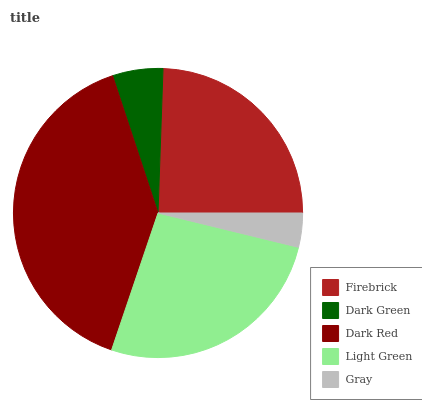Is Gray the minimum?
Answer yes or no. Yes. Is Dark Red the maximum?
Answer yes or no. Yes. Is Dark Green the minimum?
Answer yes or no. No. Is Dark Green the maximum?
Answer yes or no. No. Is Firebrick greater than Dark Green?
Answer yes or no. Yes. Is Dark Green less than Firebrick?
Answer yes or no. Yes. Is Dark Green greater than Firebrick?
Answer yes or no. No. Is Firebrick less than Dark Green?
Answer yes or no. No. Is Firebrick the high median?
Answer yes or no. Yes. Is Firebrick the low median?
Answer yes or no. Yes. Is Gray the high median?
Answer yes or no. No. Is Gray the low median?
Answer yes or no. No. 